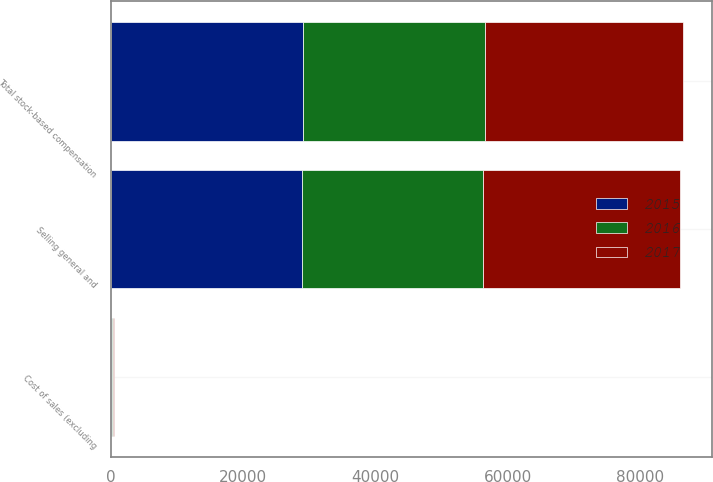<chart> <loc_0><loc_0><loc_500><loc_500><stacked_bar_chart><ecel><fcel>Cost of sales (excluding<fcel>Selling general and<fcel>Total stock-based compensation<nl><fcel>2016<fcel>220<fcel>27365<fcel>27585<nl><fcel>2015<fcel>110<fcel>28866<fcel>28976<nl><fcel>2017<fcel>108<fcel>29911<fcel>30019<nl></chart> 